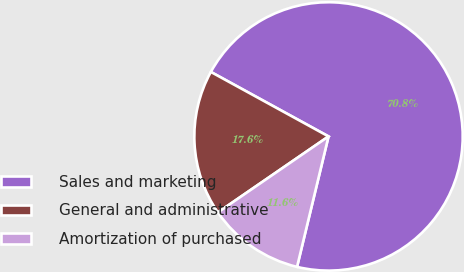Convert chart to OTSL. <chart><loc_0><loc_0><loc_500><loc_500><pie_chart><fcel>Sales and marketing<fcel>General and administrative<fcel>Amortization of purchased<nl><fcel>70.79%<fcel>17.56%<fcel>11.65%<nl></chart> 